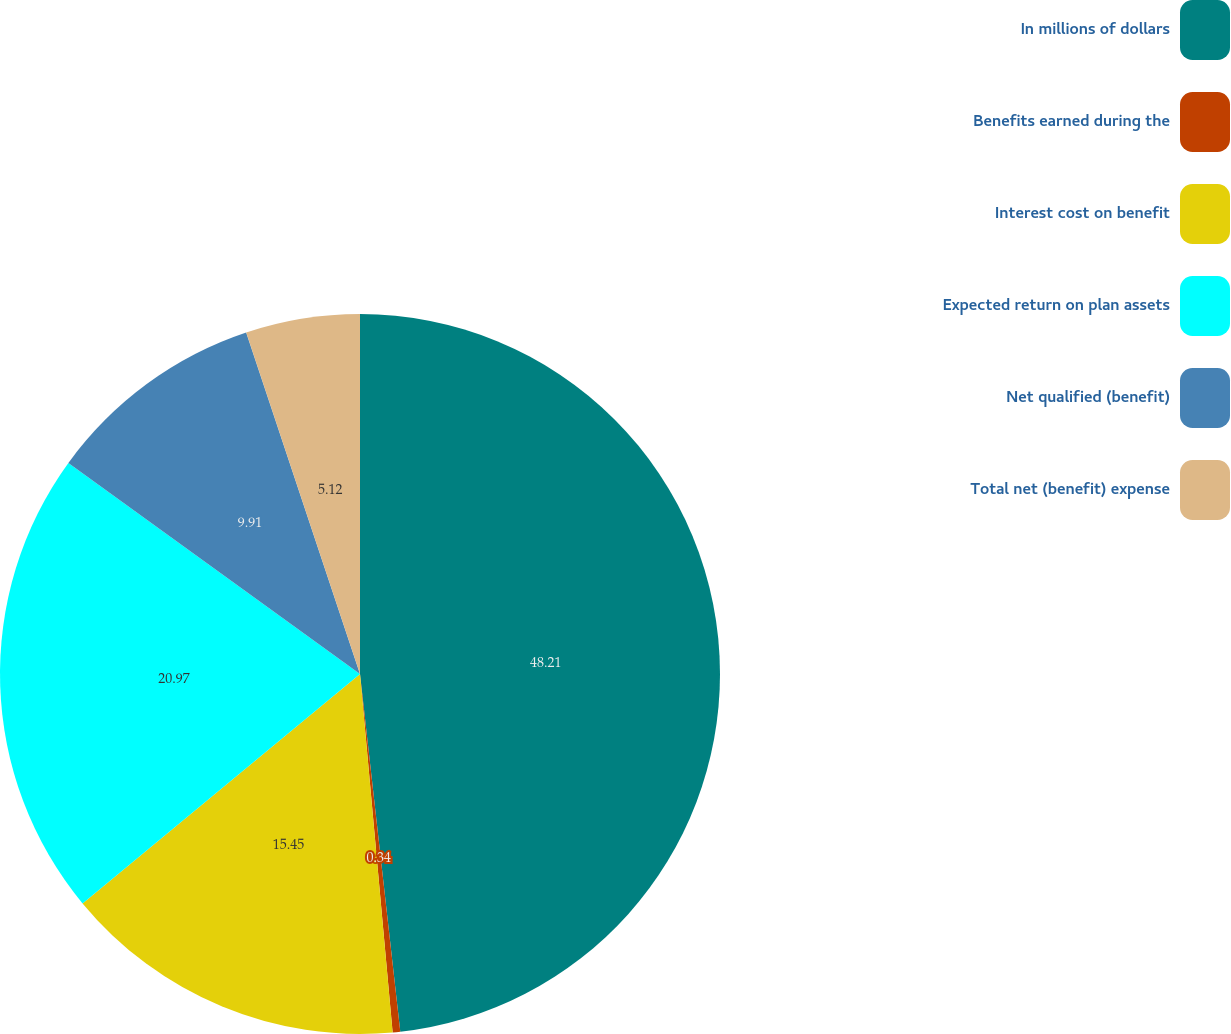<chart> <loc_0><loc_0><loc_500><loc_500><pie_chart><fcel>In millions of dollars<fcel>Benefits earned during the<fcel>Interest cost on benefit<fcel>Expected return on plan assets<fcel>Net qualified (benefit)<fcel>Total net (benefit) expense<nl><fcel>48.22%<fcel>0.34%<fcel>15.45%<fcel>20.97%<fcel>9.91%<fcel>5.12%<nl></chart> 